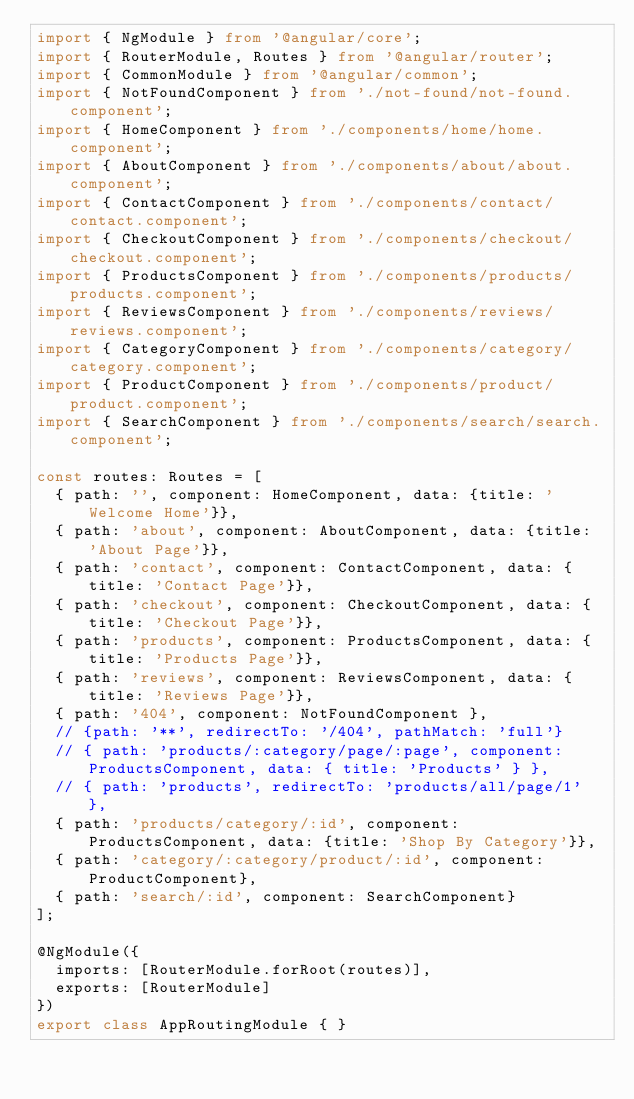Convert code to text. <code><loc_0><loc_0><loc_500><loc_500><_TypeScript_>import { NgModule } from '@angular/core';
import { RouterModule, Routes } from '@angular/router';
import { CommonModule } from '@angular/common';
import { NotFoundComponent } from './not-found/not-found.component';
import { HomeComponent } from './components/home/home.component';
import { AboutComponent } from './components/about/about.component';
import { ContactComponent } from './components/contact/contact.component';
import { CheckoutComponent } from './components/checkout/checkout.component';
import { ProductsComponent } from './components/products/products.component';
import { ReviewsComponent } from './components/reviews/reviews.component';
import { CategoryComponent } from './components/category/category.component';
import { ProductComponent } from './components/product/product.component';
import { SearchComponent } from './components/search/search.component';

const routes: Routes = [
  { path: '', component: HomeComponent, data: {title: 'Welcome Home'}},
  { path: 'about', component: AboutComponent, data: {title: 'About Page'}},
  { path: 'contact', component: ContactComponent, data: {title: 'Contact Page'}},
  { path: 'checkout', component: CheckoutComponent, data: {title: 'Checkout Page'}},
  { path: 'products', component: ProductsComponent, data: {title: 'Products Page'}},
  { path: 'reviews', component: ReviewsComponent, data: {title: 'Reviews Page'}},
  { path: '404', component: NotFoundComponent },
  // {path: '**', redirectTo: '/404', pathMatch: 'full'}
  // { path: 'products/:category/page/:page', component: ProductsComponent, data: { title: 'Products' } },
  // { path: 'products', redirectTo: 'products/all/page/1' },
  { path: 'products/category/:id', component: ProductsComponent, data: {title: 'Shop By Category'}},
  { path: 'category/:category/product/:id', component: ProductComponent},
  { path: 'search/:id', component: SearchComponent}
];

@NgModule({
  imports: [RouterModule.forRoot(routes)],
  exports: [RouterModule]
})
export class AppRoutingModule { }
</code> 